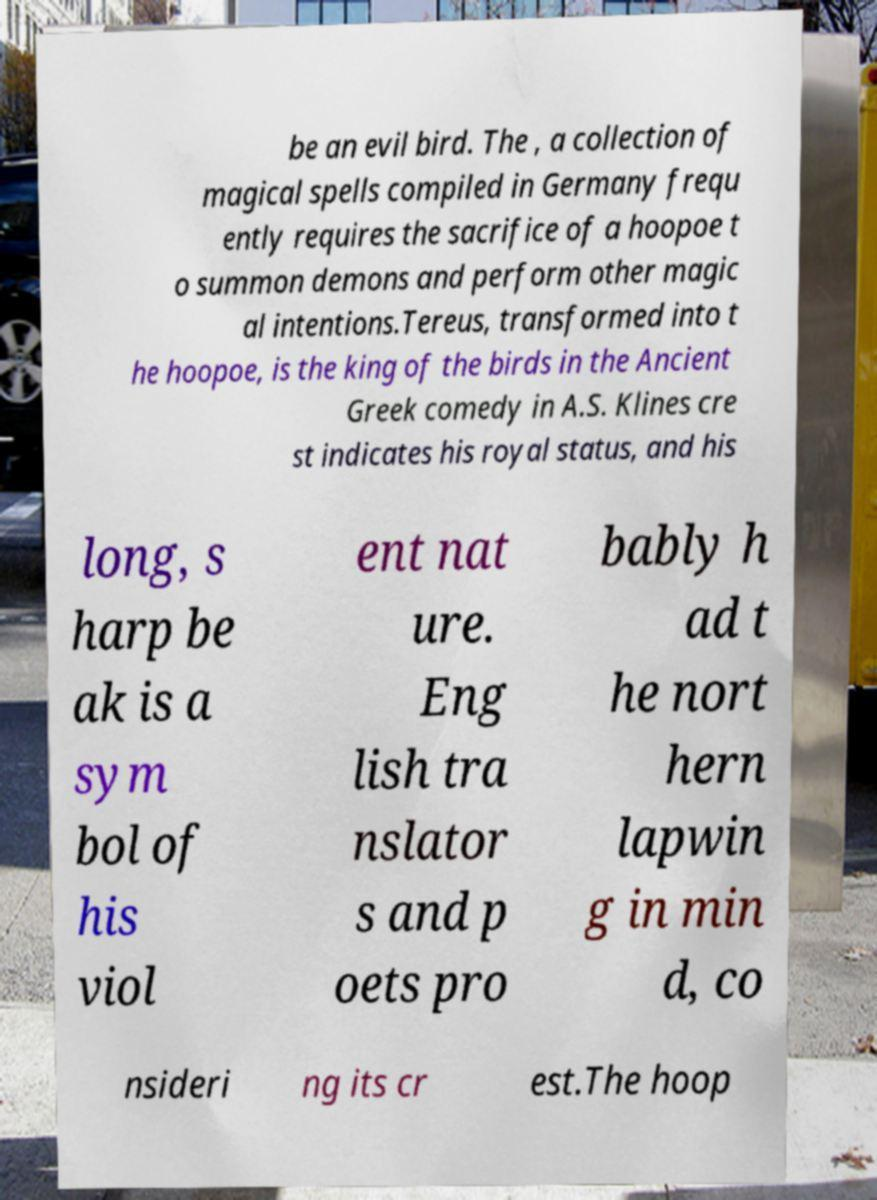What messages or text are displayed in this image? I need them in a readable, typed format. be an evil bird. The , a collection of magical spells compiled in Germany frequ ently requires the sacrifice of a hoopoe t o summon demons and perform other magic al intentions.Tereus, transformed into t he hoopoe, is the king of the birds in the Ancient Greek comedy in A.S. Klines cre st indicates his royal status, and his long, s harp be ak is a sym bol of his viol ent nat ure. Eng lish tra nslator s and p oets pro bably h ad t he nort hern lapwin g in min d, co nsideri ng its cr est.The hoop 